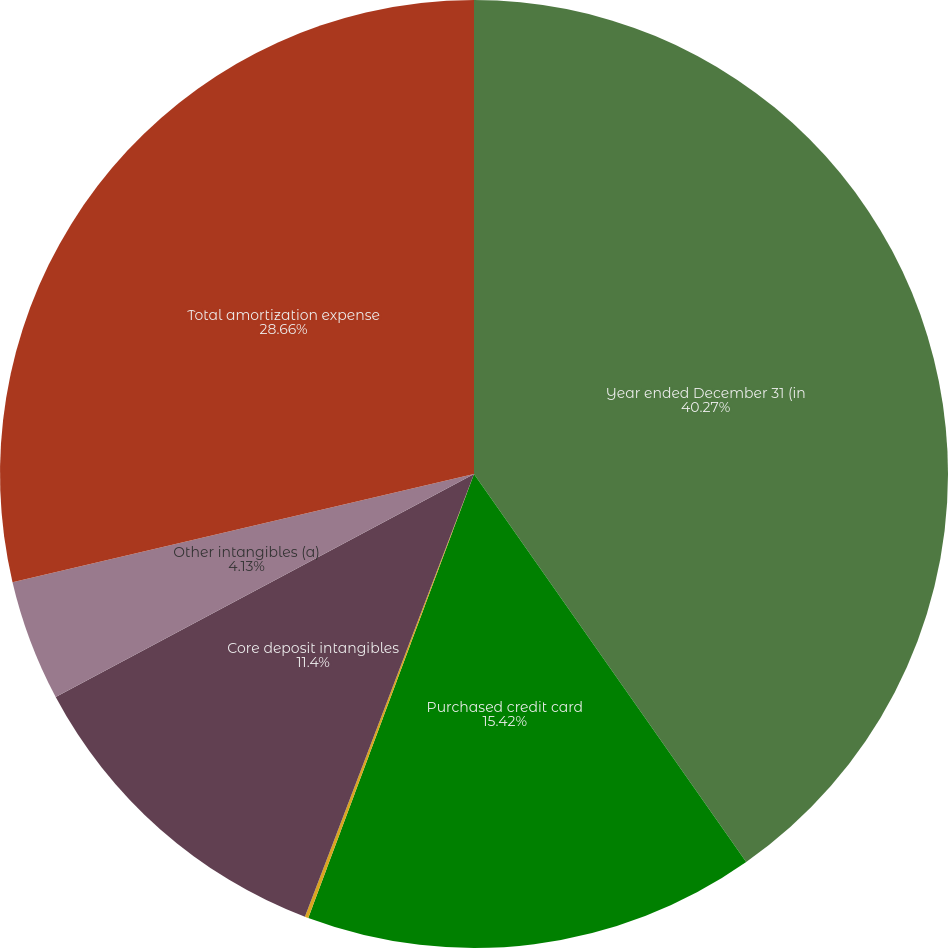Convert chart. <chart><loc_0><loc_0><loc_500><loc_500><pie_chart><fcel>Year ended December 31 (in<fcel>Purchased credit card<fcel>Other credit card-related<fcel>Core deposit intangibles<fcel>Other intangibles (a)<fcel>Total amortization expense<nl><fcel>40.26%<fcel>15.42%<fcel>0.12%<fcel>11.4%<fcel>4.13%<fcel>28.66%<nl></chart> 